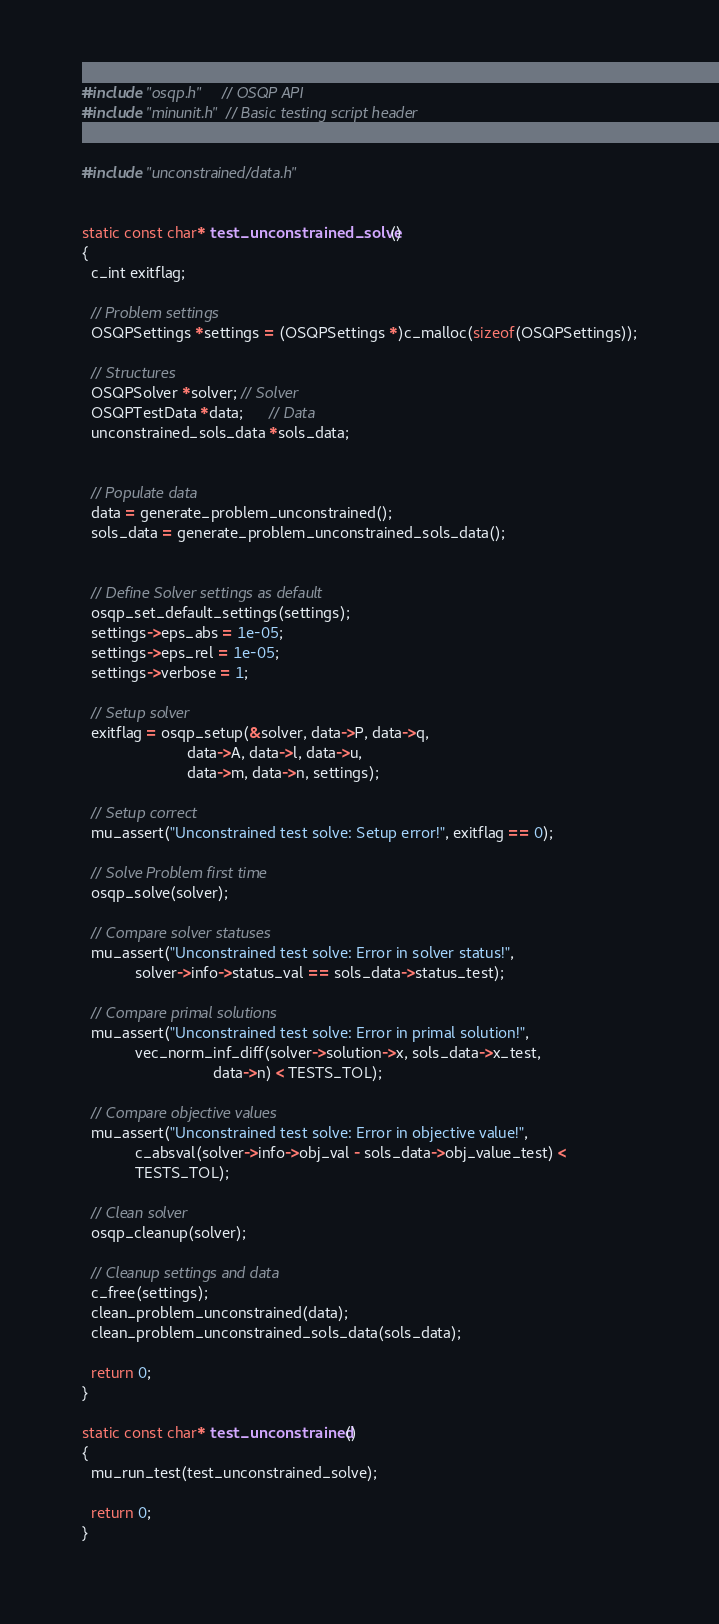<code> <loc_0><loc_0><loc_500><loc_500><_C_>#include "osqp.h"    // OSQP API
#include "minunit.h" // Basic testing script header


#include "unconstrained/data.h"


static const char* test_unconstrained_solve()
{
  c_int exitflag;

  // Problem settings
  OSQPSettings *settings = (OSQPSettings *)c_malloc(sizeof(OSQPSettings));

  // Structures
  OSQPSolver *solver; // Solver
  OSQPTestData *data;      // Data
  unconstrained_sols_data *sols_data;


  // Populate data
  data = generate_problem_unconstrained();
  sols_data = generate_problem_unconstrained_sols_data();


  // Define Solver settings as default
  osqp_set_default_settings(settings);
  settings->eps_abs = 1e-05;
  settings->eps_rel = 1e-05;
  settings->verbose = 1;

  // Setup solver
  exitflag = osqp_setup(&solver, data->P, data->q,
                        data->A, data->l, data->u,
                        data->m, data->n, settings);

  // Setup correct
  mu_assert("Unconstrained test solve: Setup error!", exitflag == 0);

  // Solve Problem first time
  osqp_solve(solver);

  // Compare solver statuses
  mu_assert("Unconstrained test solve: Error in solver status!",
            solver->info->status_val == sols_data->status_test);

  // Compare primal solutions
  mu_assert("Unconstrained test solve: Error in primal solution!",
            vec_norm_inf_diff(solver->solution->x, sols_data->x_test,
                              data->n) < TESTS_TOL);

  // Compare objective values
  mu_assert("Unconstrained test solve: Error in objective value!",
            c_absval(solver->info->obj_val - sols_data->obj_value_test) <
            TESTS_TOL);

  // Clean solver
  osqp_cleanup(solver);

  // Cleanup settings and data
  c_free(settings);
  clean_problem_unconstrained(data);
  clean_problem_unconstrained_sols_data(sols_data);

  return 0;
}

static const char* test_unconstrained()
{
  mu_run_test(test_unconstrained_solve);

  return 0;
}
</code> 